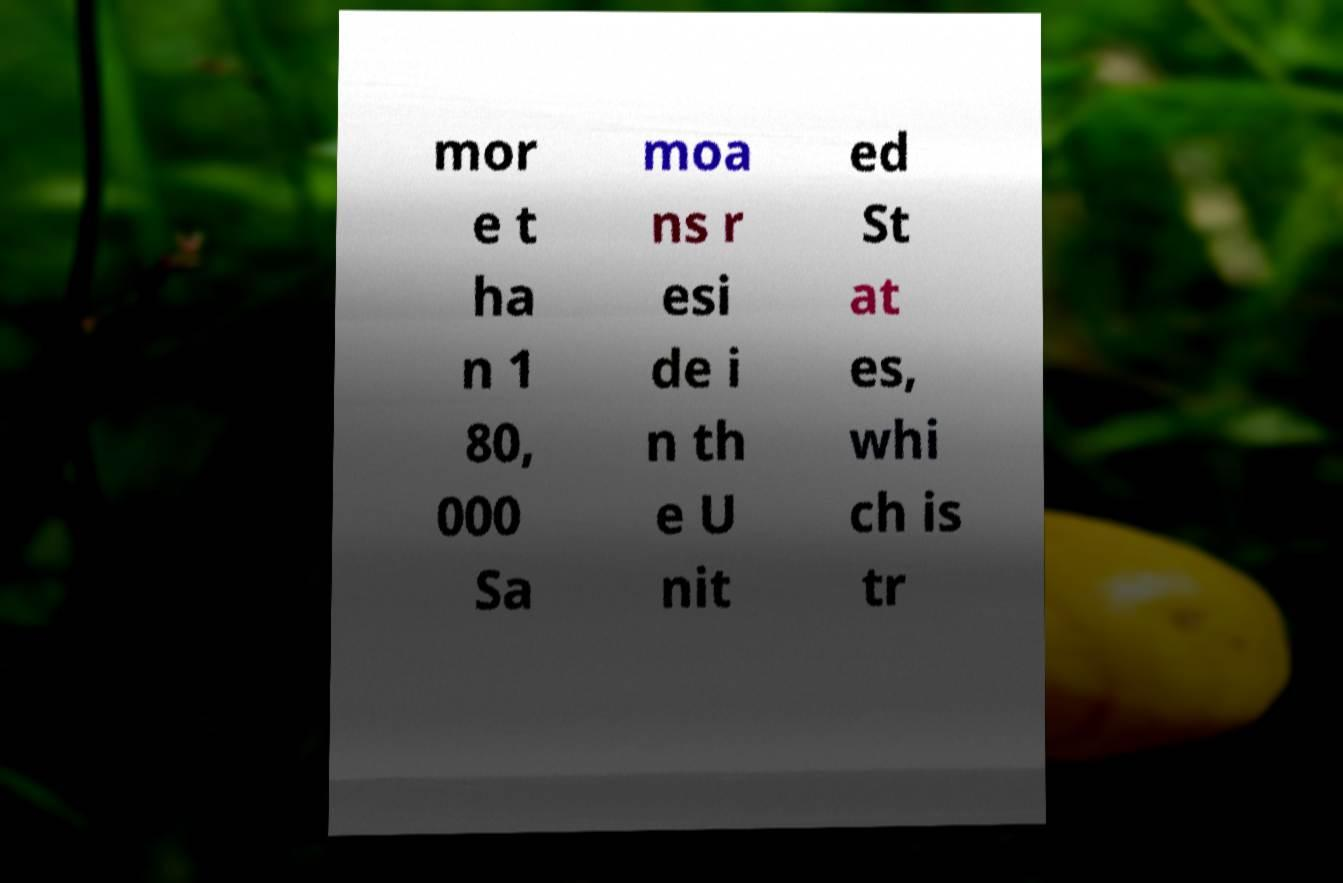What messages or text are displayed in this image? I need them in a readable, typed format. mor e t ha n 1 80, 000 Sa moa ns r esi de i n th e U nit ed St at es, whi ch is tr 